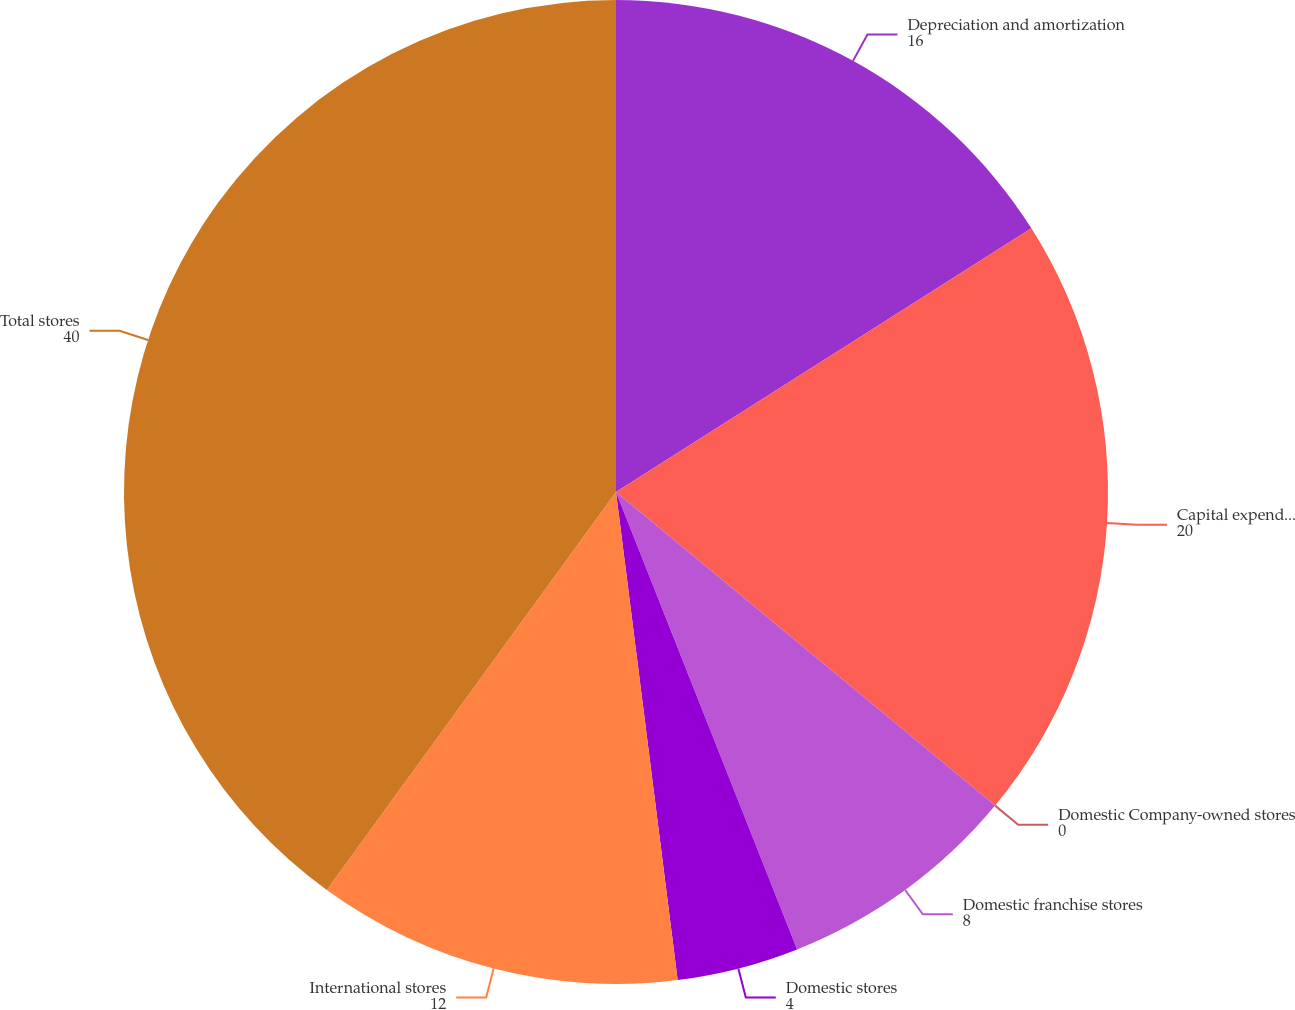Convert chart. <chart><loc_0><loc_0><loc_500><loc_500><pie_chart><fcel>Depreciation and amortization<fcel>Capital expenditures<fcel>Domestic Company-owned stores<fcel>Domestic franchise stores<fcel>Domestic stores<fcel>International stores<fcel>Total stores<nl><fcel>16.0%<fcel>20.0%<fcel>0.0%<fcel>8.0%<fcel>4.0%<fcel>12.0%<fcel>40.0%<nl></chart> 